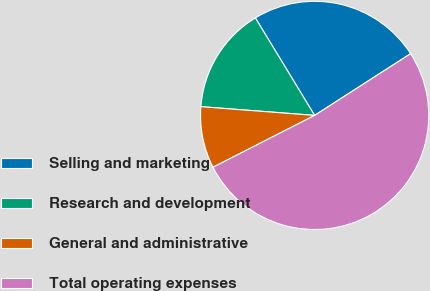<chart> <loc_0><loc_0><loc_500><loc_500><pie_chart><fcel>Selling and marketing<fcel>Research and development<fcel>General and administrative<fcel>Total operating expenses<nl><fcel>24.6%<fcel>15.08%<fcel>8.73%<fcel>51.59%<nl></chart> 